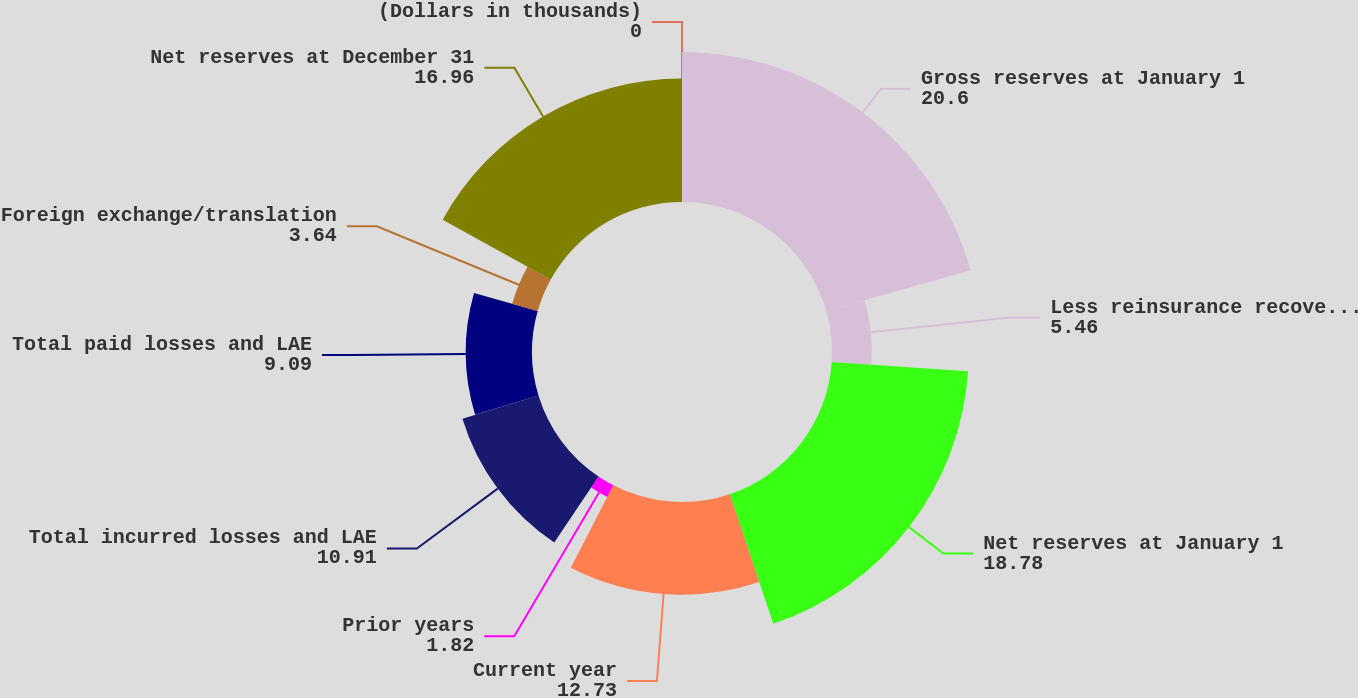Convert chart to OTSL. <chart><loc_0><loc_0><loc_500><loc_500><pie_chart><fcel>(Dollars in thousands)<fcel>Gross reserves at January 1<fcel>Less reinsurance recoverables<fcel>Net reserves at January 1<fcel>Current year<fcel>Prior years<fcel>Total incurred losses and LAE<fcel>Total paid losses and LAE<fcel>Foreign exchange/translation<fcel>Net reserves at December 31<nl><fcel>0.0%<fcel>20.6%<fcel>5.46%<fcel>18.78%<fcel>12.73%<fcel>1.82%<fcel>10.91%<fcel>9.09%<fcel>3.64%<fcel>16.96%<nl></chart> 